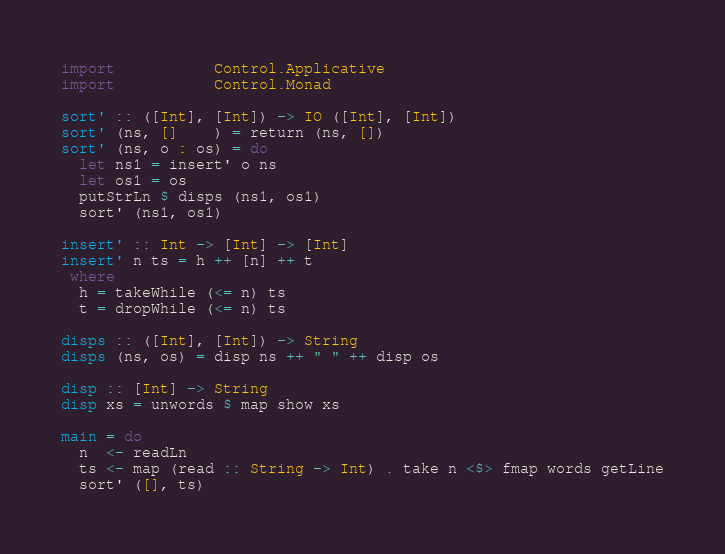Convert code to text. <code><loc_0><loc_0><loc_500><loc_500><_Haskell_>import           Control.Applicative
import           Control.Monad

sort' :: ([Int], [Int]) -> IO ([Int], [Int])
sort' (ns, []    ) = return (ns, [])
sort' (ns, o : os) = do
  let ns1 = insert' o ns
  let os1 = os
  putStrLn $ disps (ns1, os1)
  sort' (ns1, os1)

insert' :: Int -> [Int] -> [Int]
insert' n ts = h ++ [n] ++ t
 where
  h = takeWhile (<= n) ts
  t = dropWhile (<= n) ts

disps :: ([Int], [Int]) -> String
disps (ns, os) = disp ns ++ " " ++ disp os

disp :: [Int] -> String
disp xs = unwords $ map show xs

main = do
  n  <- readLn
  ts <- map (read :: String -> Int) . take n <$> fmap words getLine
  sort' ([], ts)

</code> 